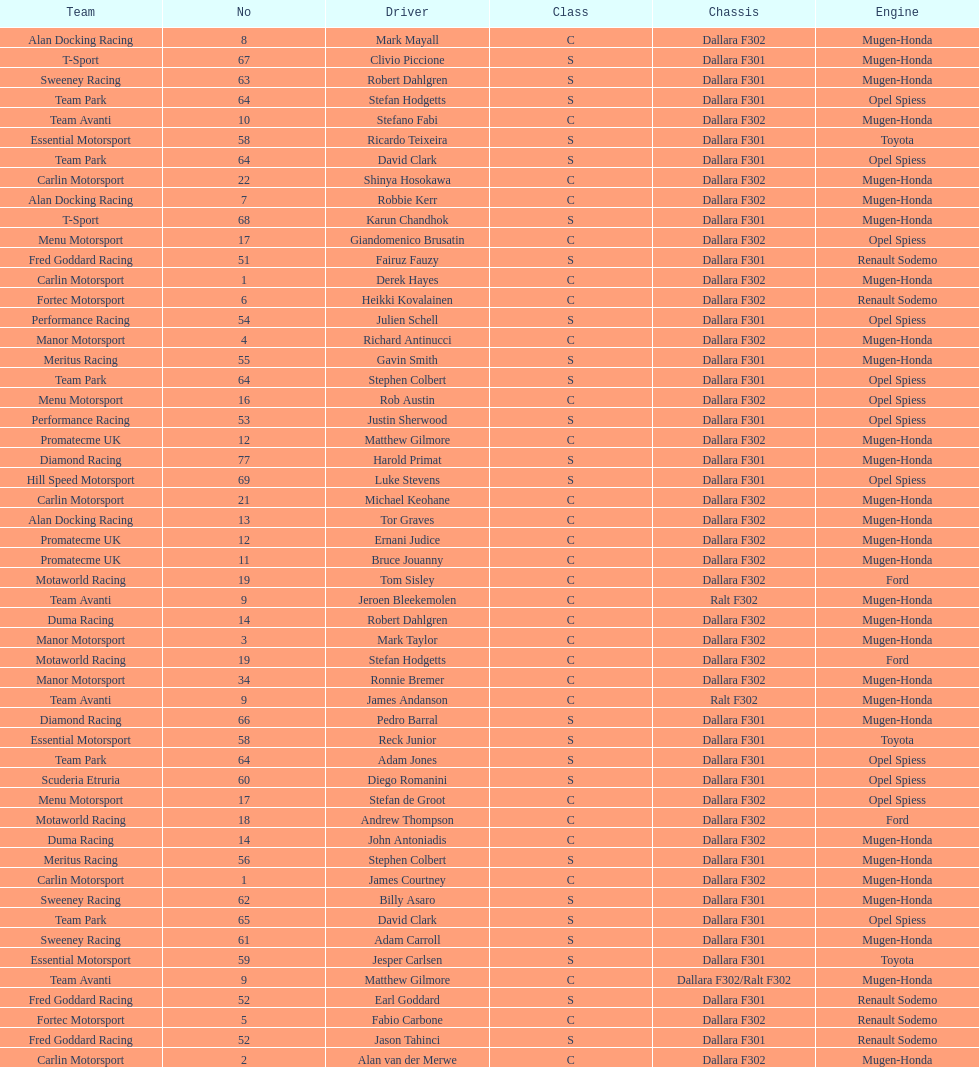How many class s (scholarship) teams are on the chart? 19. 